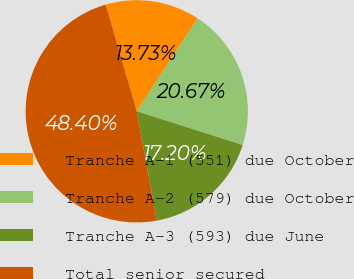Convert chart to OTSL. <chart><loc_0><loc_0><loc_500><loc_500><pie_chart><fcel>Tranche A-1 (551) due October<fcel>Tranche A-2 (579) due October<fcel>Tranche A-3 (593) due June<fcel>Total senior secured<nl><fcel>13.73%<fcel>20.67%<fcel>17.2%<fcel>48.4%<nl></chart> 